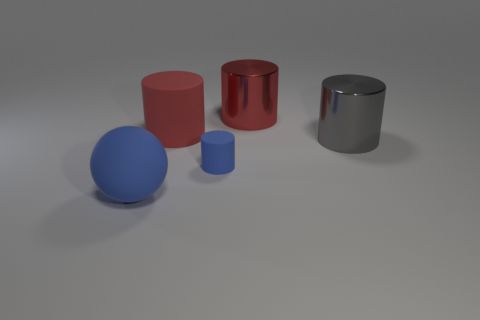Are there the same number of red shiny cylinders that are to the left of the blue rubber cylinder and spheres in front of the sphere?
Make the answer very short. Yes. There is a small object that is the same material as the large blue object; what is its color?
Provide a short and direct response. Blue. What number of small blue objects have the same material as the gray object?
Make the answer very short. 0. Does the small cylinder that is left of the red shiny thing have the same color as the big rubber sphere?
Your answer should be very brief. Yes. How many rubber things have the same shape as the big red metallic object?
Provide a succinct answer. 2. Are there the same number of shiny objects that are left of the large blue object and gray cylinders?
Offer a terse response. No. There is a matte cylinder that is the same size as the red shiny cylinder; what color is it?
Provide a short and direct response. Red. Are there any big gray things that have the same shape as the small blue thing?
Ensure brevity in your answer.  Yes. There is a object that is right of the large metal cylinder behind the large matte thing that is right of the matte sphere; what is it made of?
Your answer should be compact. Metal. What number of other things are there of the same size as the red metal cylinder?
Your answer should be very brief. 3. 